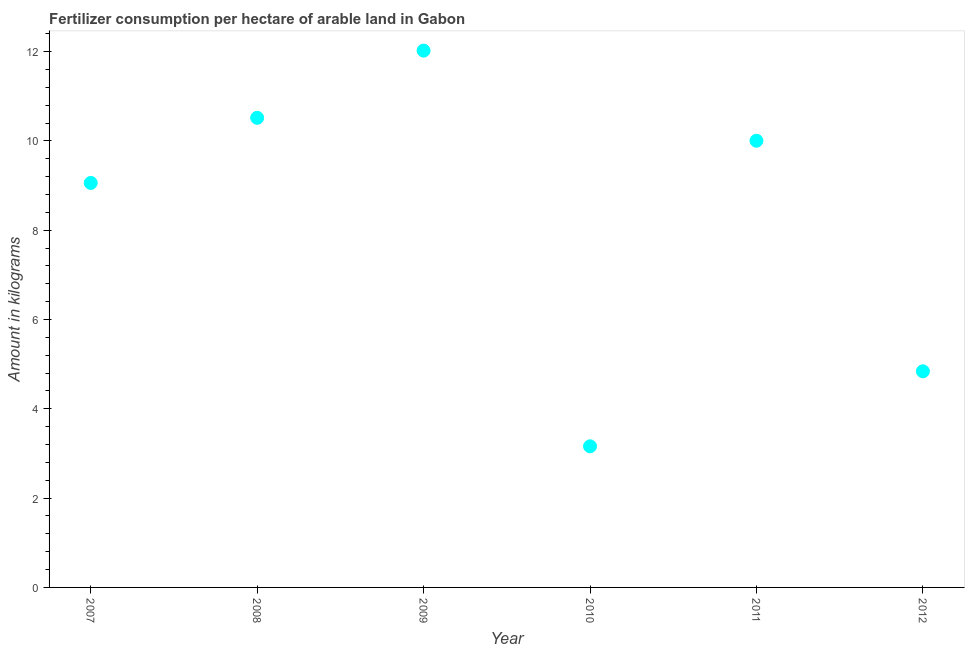What is the amount of fertilizer consumption in 2012?
Give a very brief answer. 4.84. Across all years, what is the maximum amount of fertilizer consumption?
Provide a succinct answer. 12.02. Across all years, what is the minimum amount of fertilizer consumption?
Offer a very short reply. 3.16. In which year was the amount of fertilizer consumption maximum?
Your response must be concise. 2009. What is the sum of the amount of fertilizer consumption?
Your response must be concise. 49.6. What is the difference between the amount of fertilizer consumption in 2008 and 2012?
Provide a short and direct response. 5.68. What is the average amount of fertilizer consumption per year?
Give a very brief answer. 8.27. What is the median amount of fertilizer consumption?
Keep it short and to the point. 9.53. In how many years, is the amount of fertilizer consumption greater than 8.8 kg?
Provide a short and direct response. 4. What is the ratio of the amount of fertilizer consumption in 2010 to that in 2011?
Keep it short and to the point. 0.32. What is the difference between the highest and the second highest amount of fertilizer consumption?
Your answer should be compact. 1.5. Is the sum of the amount of fertilizer consumption in 2008 and 2010 greater than the maximum amount of fertilizer consumption across all years?
Provide a succinct answer. Yes. What is the difference between the highest and the lowest amount of fertilizer consumption?
Provide a succinct answer. 8.86. In how many years, is the amount of fertilizer consumption greater than the average amount of fertilizer consumption taken over all years?
Offer a terse response. 4. Are the values on the major ticks of Y-axis written in scientific E-notation?
Provide a short and direct response. No. What is the title of the graph?
Give a very brief answer. Fertilizer consumption per hectare of arable land in Gabon . What is the label or title of the Y-axis?
Offer a terse response. Amount in kilograms. What is the Amount in kilograms in 2007?
Offer a terse response. 9.06. What is the Amount in kilograms in 2008?
Ensure brevity in your answer.  10.52. What is the Amount in kilograms in 2009?
Offer a very short reply. 12.02. What is the Amount in kilograms in 2010?
Provide a short and direct response. 3.16. What is the Amount in kilograms in 2011?
Your response must be concise. 10. What is the Amount in kilograms in 2012?
Ensure brevity in your answer.  4.84. What is the difference between the Amount in kilograms in 2007 and 2008?
Offer a very short reply. -1.46. What is the difference between the Amount in kilograms in 2007 and 2009?
Provide a succinct answer. -2.96. What is the difference between the Amount in kilograms in 2007 and 2010?
Keep it short and to the point. 5.9. What is the difference between the Amount in kilograms in 2007 and 2011?
Keep it short and to the point. -0.94. What is the difference between the Amount in kilograms in 2007 and 2012?
Your response must be concise. 4.22. What is the difference between the Amount in kilograms in 2008 and 2009?
Provide a short and direct response. -1.5. What is the difference between the Amount in kilograms in 2008 and 2010?
Offer a terse response. 7.36. What is the difference between the Amount in kilograms in 2008 and 2011?
Provide a short and direct response. 0.51. What is the difference between the Amount in kilograms in 2008 and 2012?
Provide a short and direct response. 5.68. What is the difference between the Amount in kilograms in 2009 and 2010?
Your response must be concise. 8.86. What is the difference between the Amount in kilograms in 2009 and 2011?
Keep it short and to the point. 2.02. What is the difference between the Amount in kilograms in 2009 and 2012?
Ensure brevity in your answer.  7.18. What is the difference between the Amount in kilograms in 2010 and 2011?
Offer a terse response. -6.84. What is the difference between the Amount in kilograms in 2010 and 2012?
Keep it short and to the point. -1.68. What is the difference between the Amount in kilograms in 2011 and 2012?
Provide a short and direct response. 5.16. What is the ratio of the Amount in kilograms in 2007 to that in 2008?
Make the answer very short. 0.86. What is the ratio of the Amount in kilograms in 2007 to that in 2009?
Offer a very short reply. 0.75. What is the ratio of the Amount in kilograms in 2007 to that in 2010?
Provide a short and direct response. 2.87. What is the ratio of the Amount in kilograms in 2007 to that in 2011?
Your response must be concise. 0.91. What is the ratio of the Amount in kilograms in 2007 to that in 2012?
Provide a short and direct response. 1.87. What is the ratio of the Amount in kilograms in 2008 to that in 2009?
Your response must be concise. 0.88. What is the ratio of the Amount in kilograms in 2008 to that in 2010?
Provide a short and direct response. 3.33. What is the ratio of the Amount in kilograms in 2008 to that in 2011?
Provide a succinct answer. 1.05. What is the ratio of the Amount in kilograms in 2008 to that in 2012?
Provide a short and direct response. 2.17. What is the ratio of the Amount in kilograms in 2009 to that in 2010?
Provide a short and direct response. 3.8. What is the ratio of the Amount in kilograms in 2009 to that in 2011?
Provide a short and direct response. 1.2. What is the ratio of the Amount in kilograms in 2009 to that in 2012?
Offer a very short reply. 2.48. What is the ratio of the Amount in kilograms in 2010 to that in 2011?
Offer a terse response. 0.32. What is the ratio of the Amount in kilograms in 2010 to that in 2012?
Your answer should be compact. 0.65. What is the ratio of the Amount in kilograms in 2011 to that in 2012?
Provide a short and direct response. 2.07. 